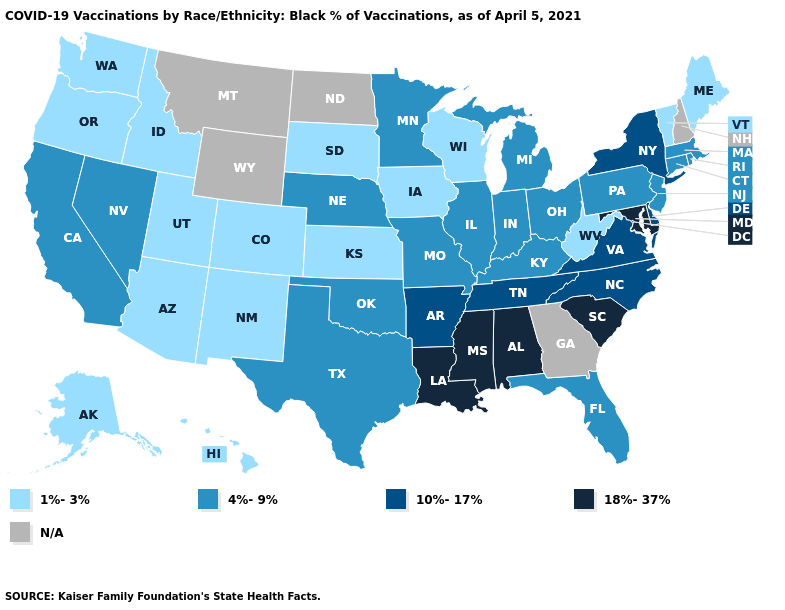What is the value of Oklahoma?
Short answer required. 4%-9%. Name the states that have a value in the range 1%-3%?
Be succinct. Alaska, Arizona, Colorado, Hawaii, Idaho, Iowa, Kansas, Maine, New Mexico, Oregon, South Dakota, Utah, Vermont, Washington, West Virginia, Wisconsin. What is the value of Minnesota?
Give a very brief answer. 4%-9%. Name the states that have a value in the range N/A?
Concise answer only. Georgia, Montana, New Hampshire, North Dakota, Wyoming. Does Alaska have the lowest value in the USA?
Answer briefly. Yes. Name the states that have a value in the range 18%-37%?
Concise answer only. Alabama, Louisiana, Maryland, Mississippi, South Carolina. What is the highest value in states that border Nebraska?
Give a very brief answer. 4%-9%. Name the states that have a value in the range 18%-37%?
Short answer required. Alabama, Louisiana, Maryland, Mississippi, South Carolina. Does the first symbol in the legend represent the smallest category?
Write a very short answer. Yes. Name the states that have a value in the range N/A?
Write a very short answer. Georgia, Montana, New Hampshire, North Dakota, Wyoming. What is the value of Rhode Island?
Be succinct. 4%-9%. Name the states that have a value in the range 1%-3%?
Write a very short answer. Alaska, Arizona, Colorado, Hawaii, Idaho, Iowa, Kansas, Maine, New Mexico, Oregon, South Dakota, Utah, Vermont, Washington, West Virginia, Wisconsin. What is the value of Maine?
Give a very brief answer. 1%-3%. What is the highest value in the USA?
Short answer required. 18%-37%. Among the states that border Connecticut , which have the lowest value?
Give a very brief answer. Massachusetts, Rhode Island. 